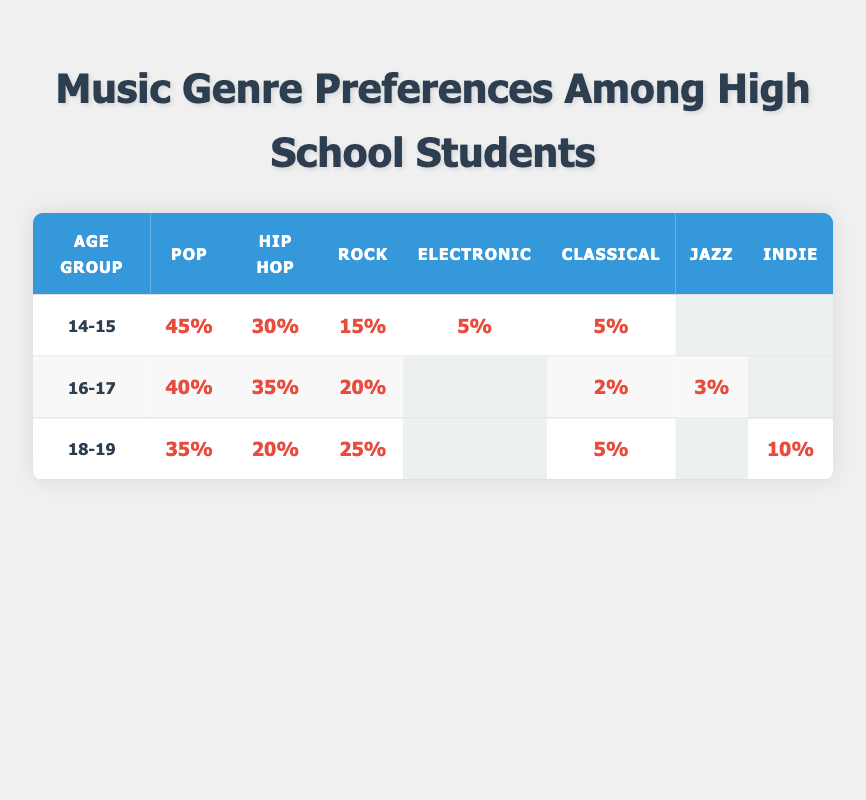What is the most preferred music genre among the 14-15 age group? The preference percentages for the 14-15 age group indicate that Pop has the highest percentage at 45%.
Answer: Pop Which age group has the least preference for Classical music? By comparing the percentages for Classical music across all age groups, 18-19 has the lowest preference at 5%.
Answer: 18-19 What percentage of 16-17 year-olds prefer Hip Hop? According to the table, the percentage of 16-17 year-olds who prefer Hip Hop is 35%.
Answer: 35% Is Jazz a preferred genre among any of the age groups? The table shows that Jazz has a preference of 3% for the 16-17 age group, and 0% preference in other age groups, confirming it is only preferred by one age group.
Answer: Yes What is the total preference for Pop across all age groups? The total preference for Pop is calculated by adding the percentages: 45% (14-15) + 40% (16-17) + 35% (18-19) = 120%.
Answer: 120% Which genre is preferred by the most balanced percentage among the three age groups? By comparing each genre's percentages across all age groups, Rock has a consistent presence with 15%, 20%, and 25%, respectively, showing a more balanced preference compared to others.
Answer: Rock What genre shows a declining trend from the 14-15 to the 18-19 age group? Examining the percentage preferences, Pop shows a decline from 45% (14-15) to 35% (18-19), indicating a downward trend.
Answer: Pop How many genres have a preference of 5% or higher in the 14-15 age group? Looking at the 14-15 age group's preferences, there are three genres with 5% or higher: Pop (45%), Hip Hop (30%), and Rock (15%).
Answer: 3 What is the average preference percentage for Electronic music across all age groups? Electronic music has a preference percentage of 5% in the 14-15 group, 0% in the 16-17 group, and 0% in the 18-19 group. Thus, the average is (5 + 0 + 0) / 3 = 1.67%.
Answer: 1.67% Which age group has a higher preference for Rock compared to Hip Hop? By comparing the preferences, the 18-19 age group has 25% for Rock and only 20% for Hip Hop, indicating a higher preference for Rock in this group.
Answer: 18-19 